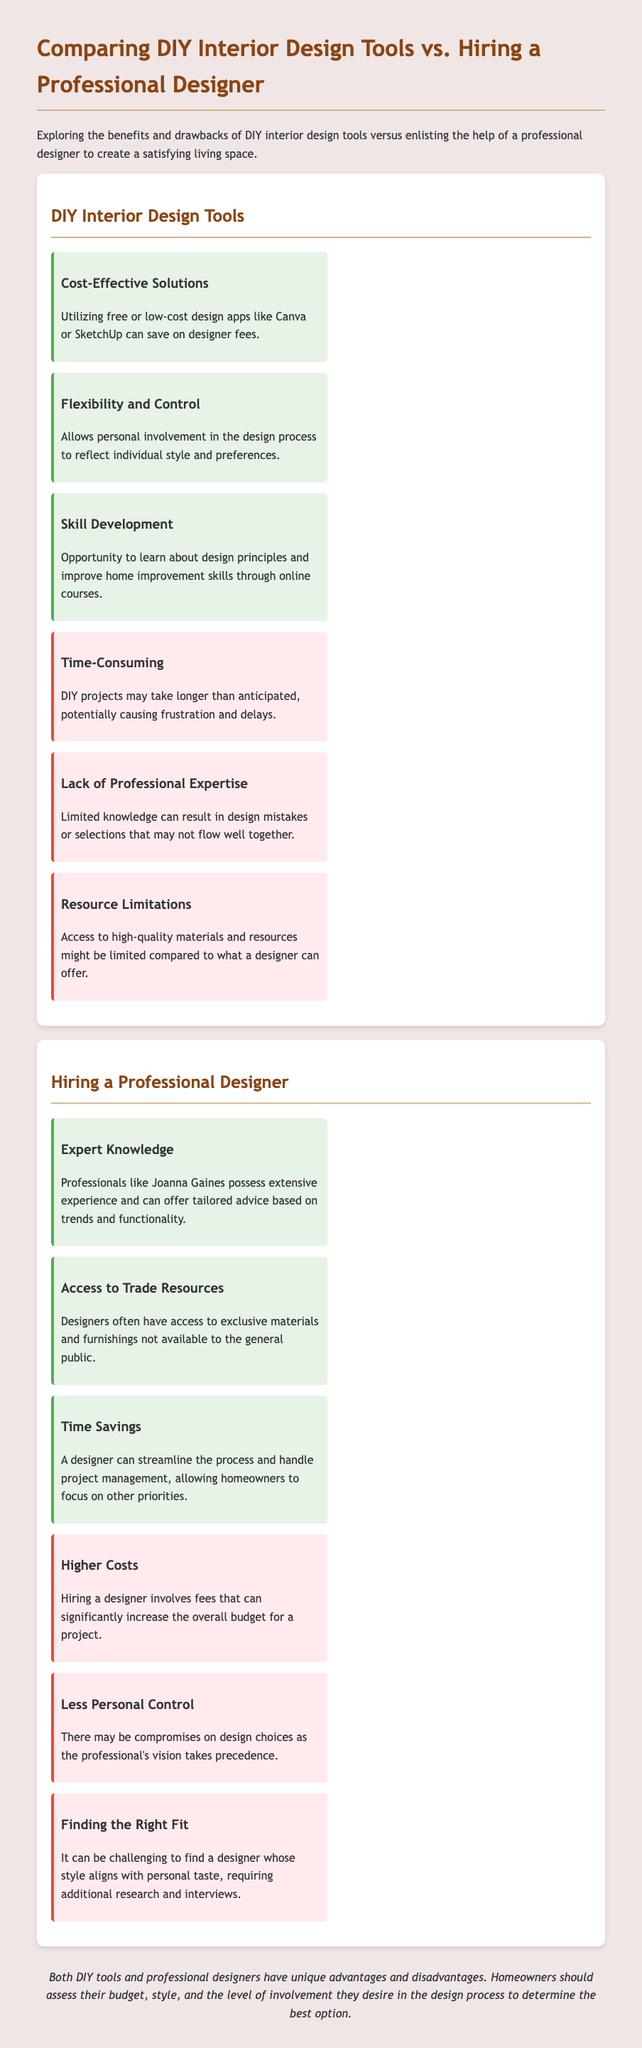What is a benefit of DIY interior design tools? One benefit listed in the document is that they offer cost-effective solutions.
Answer: Cost-Effective Solutions What is a drawback of hiring a professional designer? The document states that a significant drawback is the higher costs associated with hiring a designer.
Answer: Higher Costs What does hiring a professional designer offer access to? The document mentions that hiring a designer offers access to exclusive materials and furnishings.
Answer: Trade Resources How does DIY involvement affect control in the design process? According to the document, DIY involvement allows for personal control in the design process.
Answer: Flexibility and Control What is a primary reason time savings are advantageous when hiring a designer? The document states that a designer can streamline the process and manage projects, saving homeowners time.
Answer: Time Savings Which benefit pertains to skill enhancement in DIY design? The document highlights that DIY tools provide an opportunity for skill development in design principles.
Answer: Skill Development What challenge is mentioned regarding finding a professional designer? The document indicates that it can be challenging to find a designer whose style aligns with personal taste.
Answer: Finding the Right Fit What type of knowledge do professional designers possess? The document emphasizes that professionals have expert knowledge that includes experience and tailored advice.
Answer: Expert Knowledge 